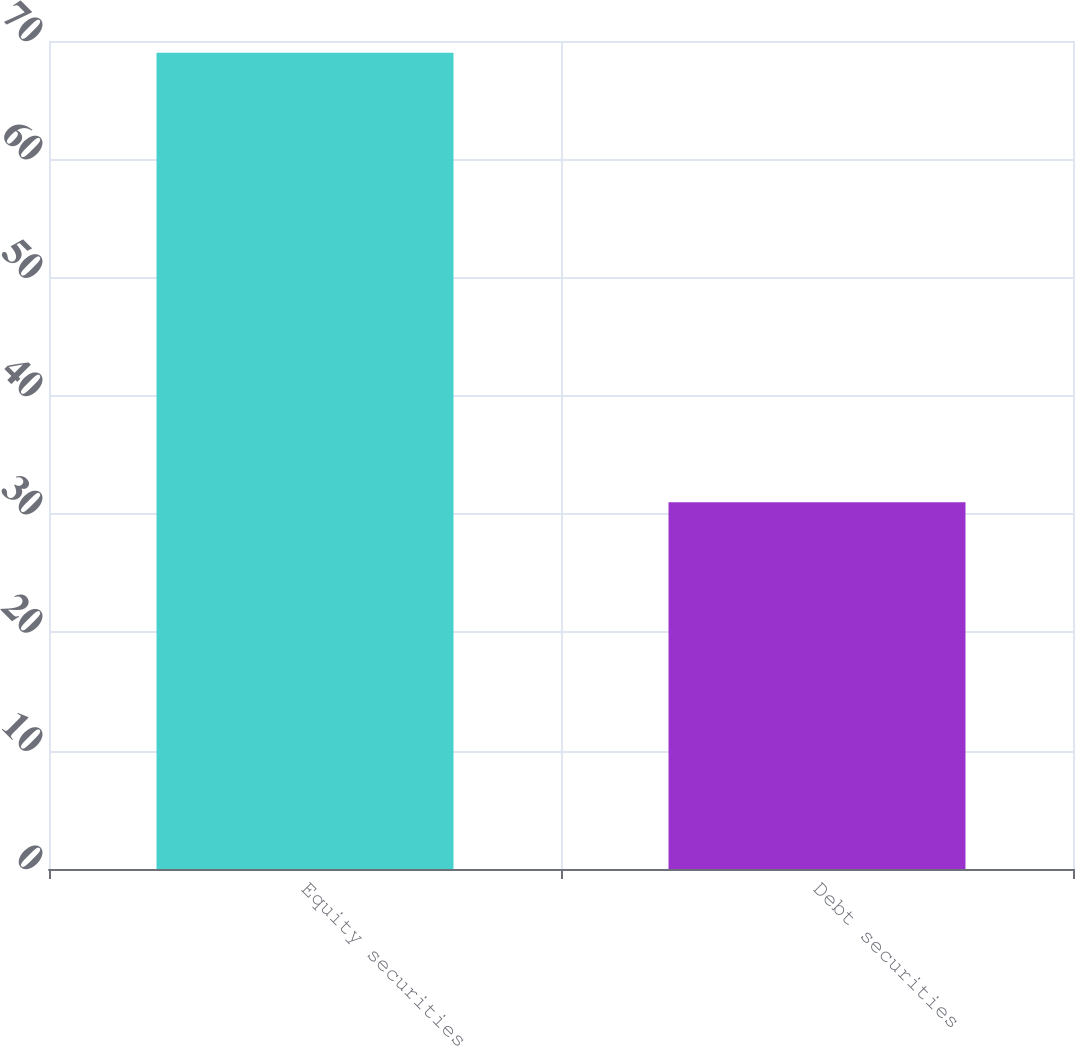<chart> <loc_0><loc_0><loc_500><loc_500><bar_chart><fcel>Equity securities<fcel>Debt securities<nl><fcel>69<fcel>31<nl></chart> 